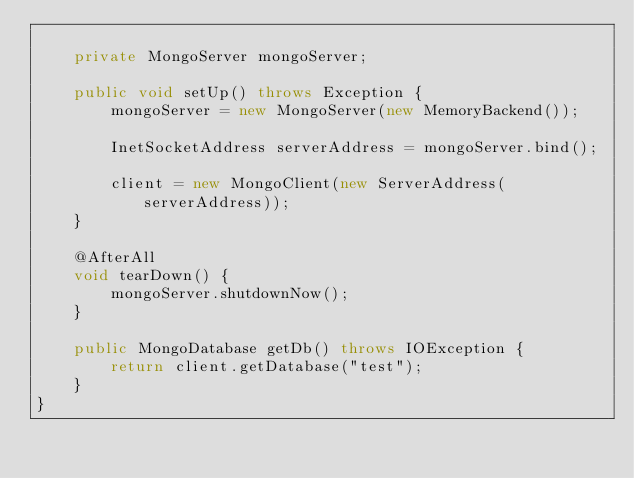<code> <loc_0><loc_0><loc_500><loc_500><_Java_>
    private MongoServer mongoServer;

    public void setUp() throws Exception {
        mongoServer = new MongoServer(new MemoryBackend());

        InetSocketAddress serverAddress = mongoServer.bind();

        client = new MongoClient(new ServerAddress(serverAddress));
    }

    @AfterAll
    void tearDown() {
        mongoServer.shutdownNow();
    }

    public MongoDatabase getDb() throws IOException {
        return client.getDatabase("test");
    }
}
</code> 